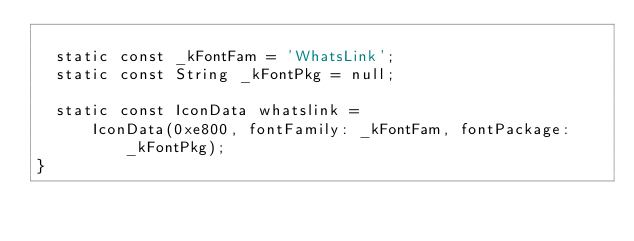<code> <loc_0><loc_0><loc_500><loc_500><_Dart_>
  static const _kFontFam = 'WhatsLink';
  static const String _kFontPkg = null;

  static const IconData whatslink =
      IconData(0xe800, fontFamily: _kFontFam, fontPackage: _kFontPkg);
}
</code> 